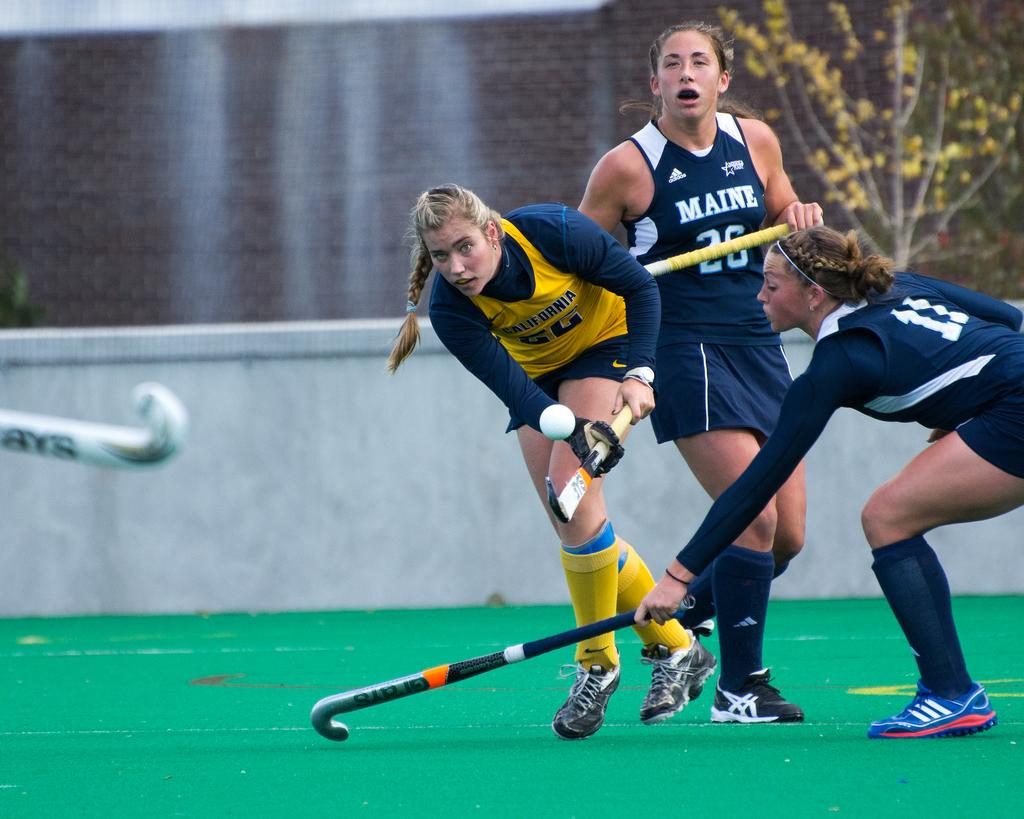<image>
Offer a succinct explanation of the picture presented. Young women compete against each other, one team in Maine uniforms and the other team in California uniforms. 